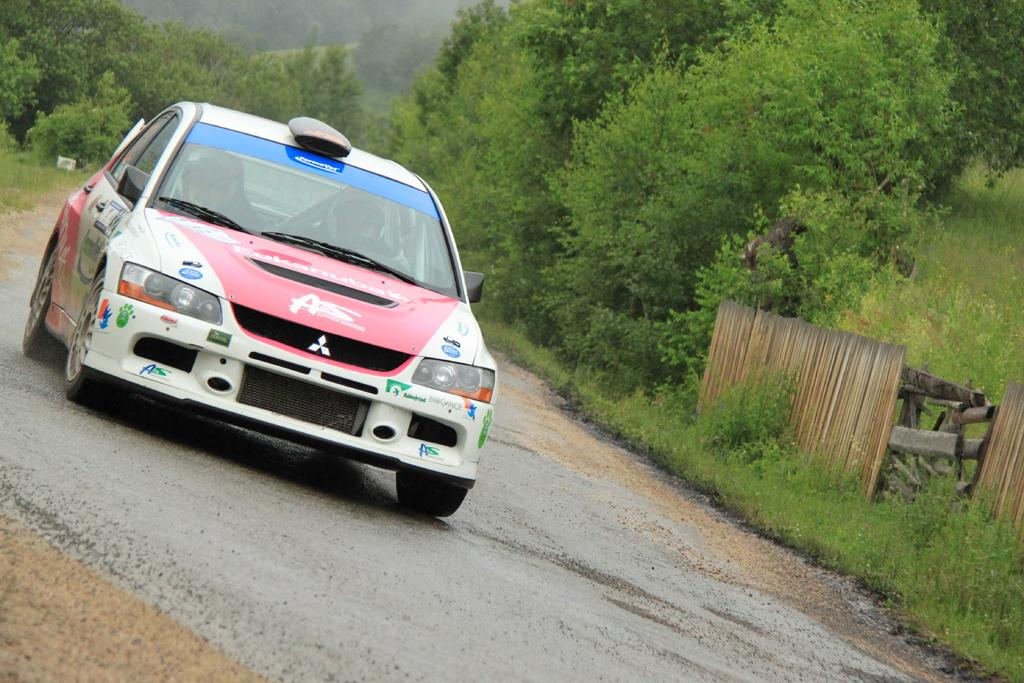What is the main subject of the image? There is a car on the road in the image. What other objects can be seen in the image besides the car? There are wooden objects, plants, and trees in the image. Can you describe the background of the image? The background of the image is blurry. What type of cable is being used for reading in the image? There is no cable or reading activity present in the image. 